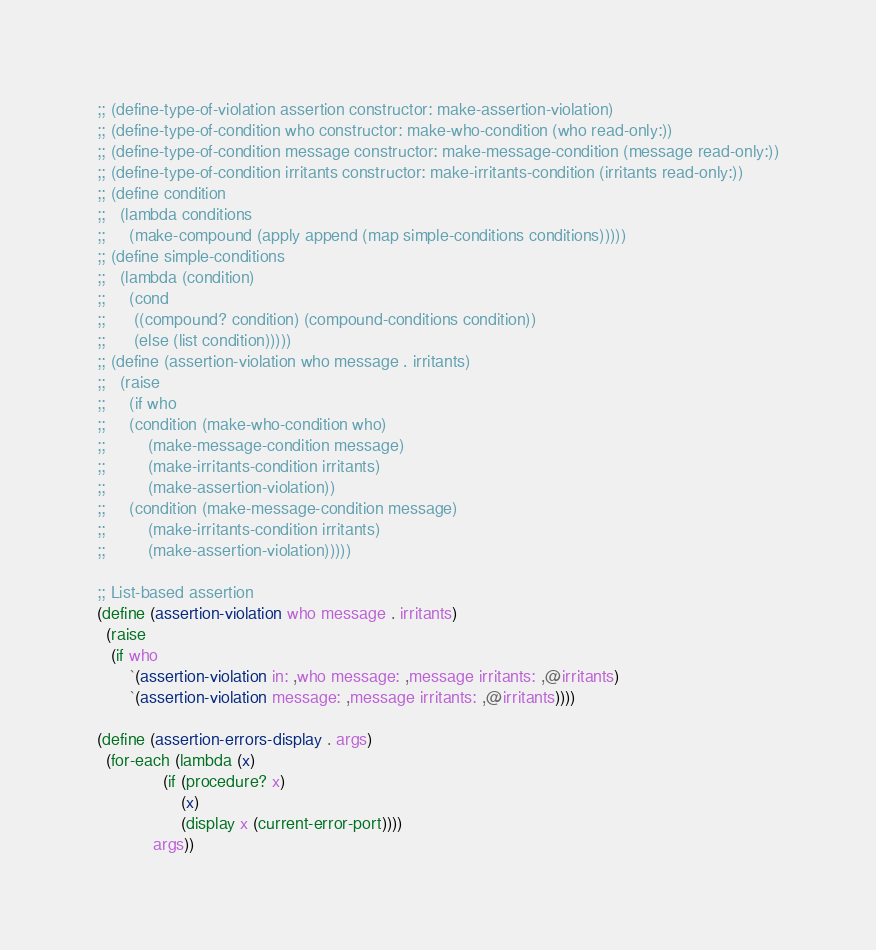Convert code to text. <code><loc_0><loc_0><loc_500><loc_500><_Scheme_>;; (define-type-of-violation assertion constructor: make-assertion-violation)
;; (define-type-of-condition who constructor: make-who-condition (who read-only:))
;; (define-type-of-condition message constructor: make-message-condition (message read-only:))
;; (define-type-of-condition irritants constructor: make-irritants-condition (irritants read-only:))
;; (define condition
;;   (lambda conditions
;;     (make-compound (apply append (map simple-conditions conditions))))) 
;; (define simple-conditions
;;   (lambda (condition)
;;     (cond
;;      ((compound? condition) (compound-conditions condition))
;;      (else (list condition)))))
;; (define (assertion-violation who message . irritants)
;;   (raise 
;;     (if who
;;     (condition (make-who-condition who) 
;;         (make-message-condition message) 
;;         (make-irritants-condition irritants)
;;         (make-assertion-violation))
;;     (condition (make-message-condition message) 
;;         (make-irritants-condition irritants)
;;         (make-assertion-violation)))))

;; List-based assertion
(define (assertion-violation who message . irritants)
  (raise
   (if who
       `(assertion-violation in: ,who message: ,message irritants: ,@irritants)
       `(assertion-violation message: ,message irritants: ,@irritants))))

(define (assertion-errors-display . args)
  (for-each (lambda (x)
              (if (procedure? x)
                  (x)
                  (display x (current-error-port))))
            args))
</code> 